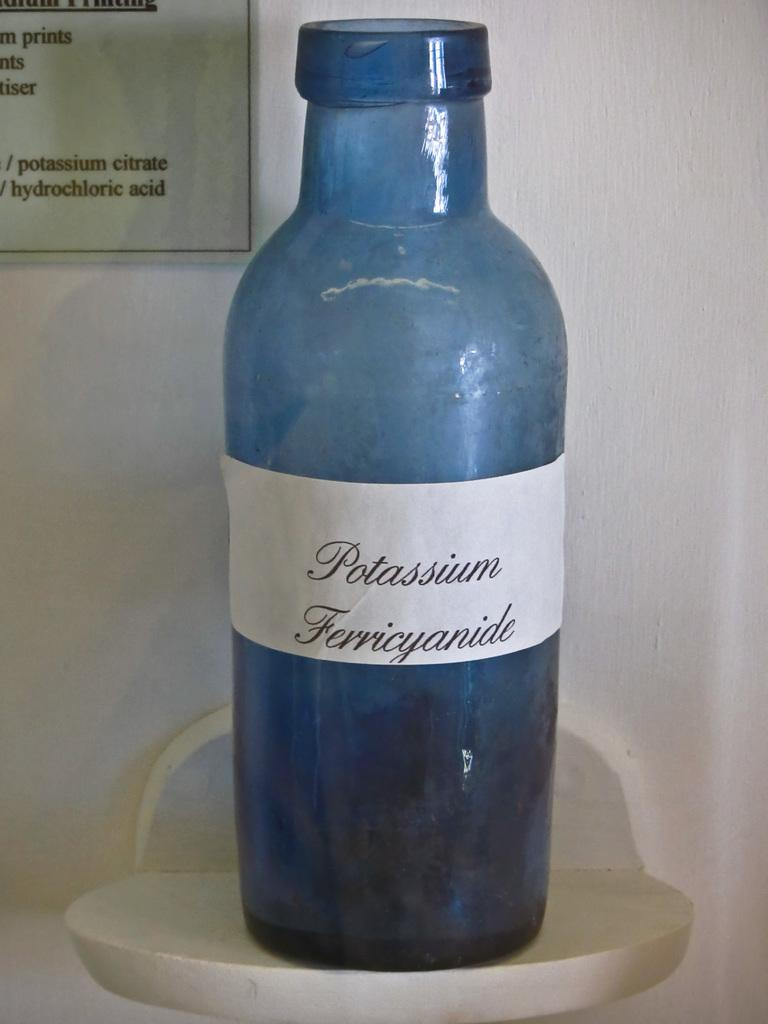Provide a one-sentence caption for the provided image. A blue glass bottle of Potassium Ferricyanide on a shelf. 